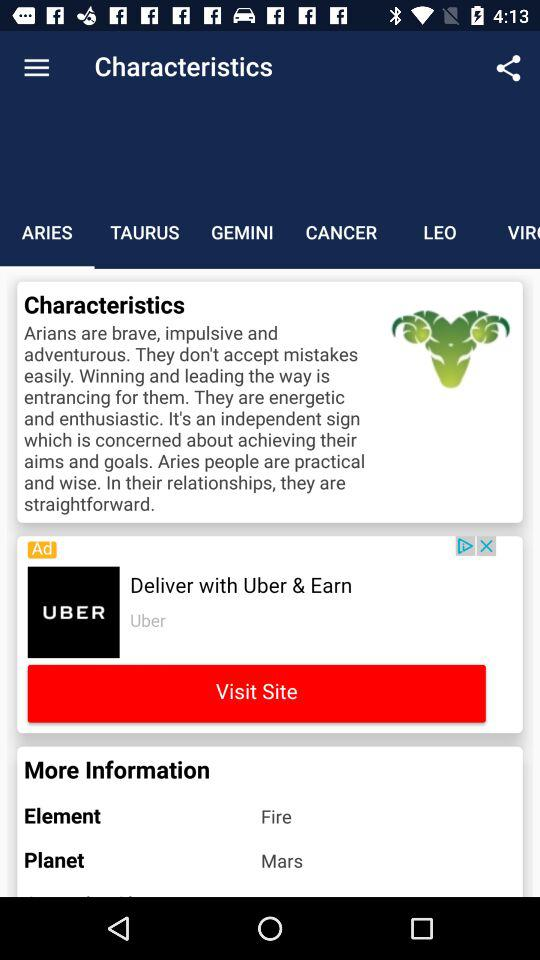Which tab is selected? The selected tab is "ARIES". 